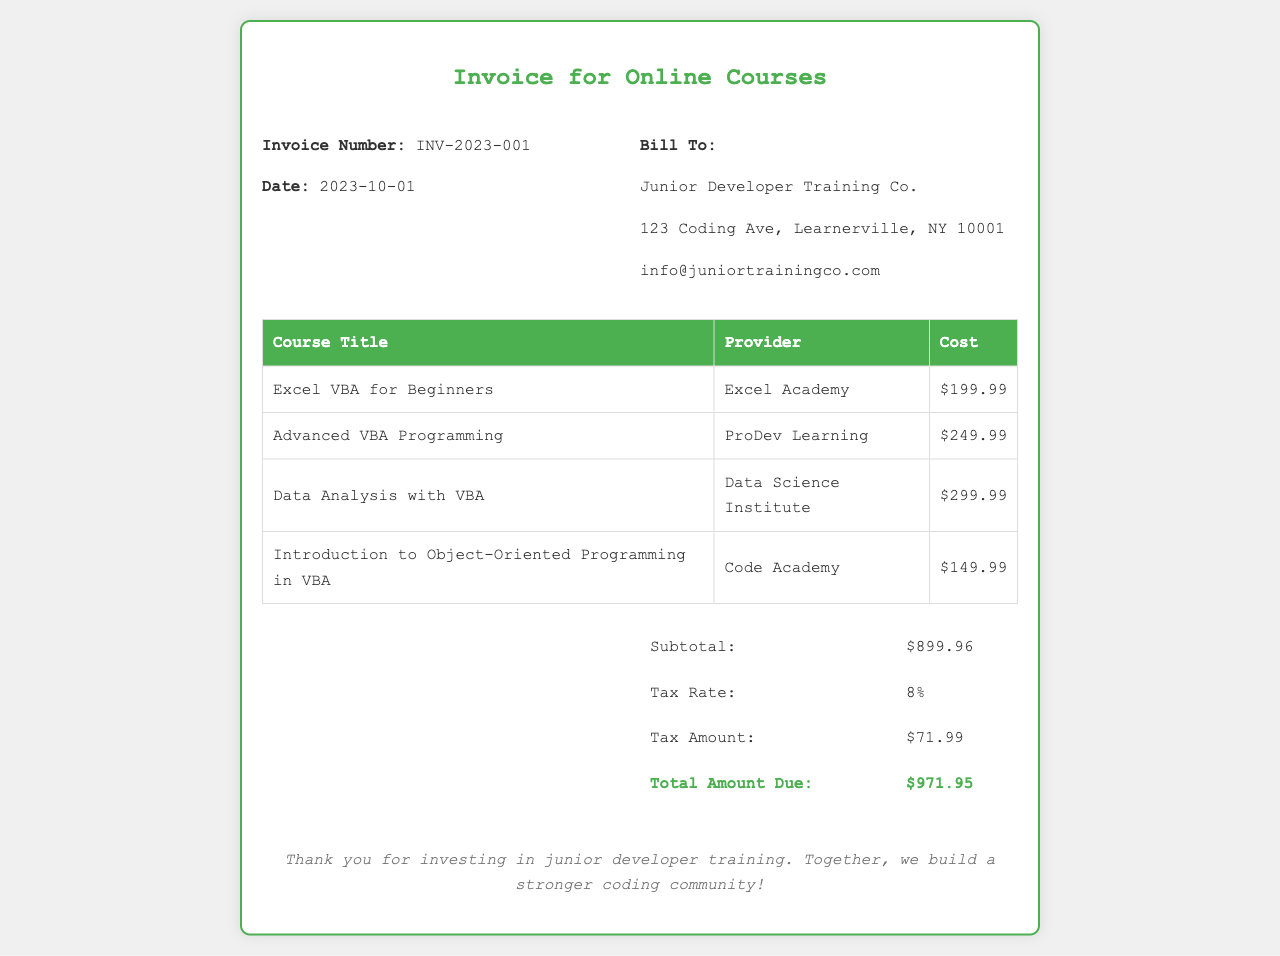What is the invoice number? The invoice number is a unique identifier for this invoice, which is listed in the document.
Answer: INV-2023-001 What is the date of the invoice? The date represents when the invoice was issued, as specified in the document.
Answer: 2023-10-01 What is the total amount due? The total amount due is the final amount that needs to be paid, which includes subtotal and tax.
Answer: $971.95 How much is the cost of 'Advanced VBA Programming'? The specific course cost is detailed in the table within the document.
Answer: $249.99 Which company is the bill addressed to? The bill-to section indicates the recipient of the invoice.
Answer: Junior Developer Training Co What is the subtotal amount? The subtotal is the sum of all course costs before tax, as shown in the total section.
Answer: $899.96 What is the tax rate applied? The tax rate indicates the percentage of tax applied to the subtotal, as stated in the document.
Answer: 8% Who is the provider for 'Data Analysis with VBA'? The provider name is specified next to the course title in the table.
Answer: Data Science Institute What is included in the footer of the invoice? The footer contains a closing remark thanking the recipient, which is important for establishing rapport.
Answer: Thank you for investing in junior developer training. Together, we build a stronger coding community! 